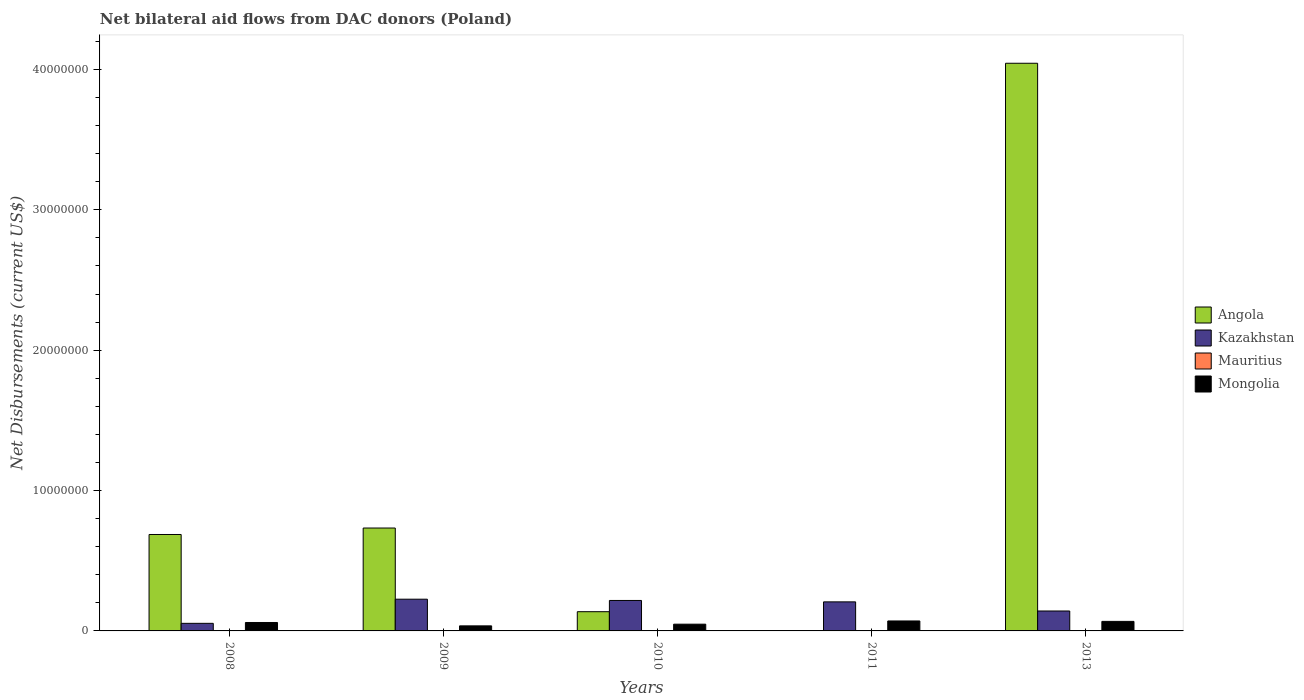How many groups of bars are there?
Your answer should be compact. 5. Are the number of bars per tick equal to the number of legend labels?
Your answer should be compact. No. How many bars are there on the 1st tick from the left?
Offer a terse response. 4. How many bars are there on the 1st tick from the right?
Ensure brevity in your answer.  4. What is the label of the 1st group of bars from the left?
Offer a terse response. 2008. In how many cases, is the number of bars for a given year not equal to the number of legend labels?
Provide a succinct answer. 1. What is the net bilateral aid flows in Mongolia in 2011?
Ensure brevity in your answer.  7.10e+05. Across all years, what is the maximum net bilateral aid flows in Kazakhstan?
Offer a very short reply. 2.26e+06. In which year was the net bilateral aid flows in Mauritius maximum?
Offer a very short reply. 2008. What is the total net bilateral aid flows in Mauritius in the graph?
Provide a succinct answer. 6.00e+04. What is the difference between the net bilateral aid flows in Kazakhstan in 2011 and that in 2013?
Ensure brevity in your answer.  6.50e+05. What is the difference between the net bilateral aid flows in Angola in 2011 and the net bilateral aid flows in Mongolia in 2009?
Offer a terse response. -3.60e+05. What is the average net bilateral aid flows in Angola per year?
Keep it short and to the point. 1.12e+07. In the year 2013, what is the difference between the net bilateral aid flows in Angola and net bilateral aid flows in Mongolia?
Keep it short and to the point. 3.98e+07. In how many years, is the net bilateral aid flows in Mongolia greater than 20000000 US$?
Your answer should be compact. 0. What is the ratio of the net bilateral aid flows in Mongolia in 2010 to that in 2011?
Provide a short and direct response. 0.68. Is the difference between the net bilateral aid flows in Angola in 2008 and 2013 greater than the difference between the net bilateral aid flows in Mongolia in 2008 and 2013?
Your answer should be very brief. No. What is the difference between the highest and the second highest net bilateral aid flows in Kazakhstan?
Offer a very short reply. 9.00e+04. What is the difference between the highest and the lowest net bilateral aid flows in Mongolia?
Ensure brevity in your answer.  3.50e+05. In how many years, is the net bilateral aid flows in Mauritius greater than the average net bilateral aid flows in Mauritius taken over all years?
Keep it short and to the point. 1. Is it the case that in every year, the sum of the net bilateral aid flows in Mauritius and net bilateral aid flows in Mongolia is greater than the sum of net bilateral aid flows in Kazakhstan and net bilateral aid flows in Angola?
Keep it short and to the point. No. Is it the case that in every year, the sum of the net bilateral aid flows in Kazakhstan and net bilateral aid flows in Angola is greater than the net bilateral aid flows in Mauritius?
Provide a short and direct response. Yes. Are all the bars in the graph horizontal?
Ensure brevity in your answer.  No. What is the difference between two consecutive major ticks on the Y-axis?
Ensure brevity in your answer.  1.00e+07. Where does the legend appear in the graph?
Provide a succinct answer. Center right. How are the legend labels stacked?
Your answer should be very brief. Vertical. What is the title of the graph?
Provide a short and direct response. Net bilateral aid flows from DAC donors (Poland). Does "Northern Mariana Islands" appear as one of the legend labels in the graph?
Offer a terse response. No. What is the label or title of the X-axis?
Provide a succinct answer. Years. What is the label or title of the Y-axis?
Give a very brief answer. Net Disbursements (current US$). What is the Net Disbursements (current US$) in Angola in 2008?
Keep it short and to the point. 6.87e+06. What is the Net Disbursements (current US$) of Kazakhstan in 2008?
Keep it short and to the point. 5.40e+05. What is the Net Disbursements (current US$) of Mauritius in 2008?
Offer a very short reply. 2.00e+04. What is the Net Disbursements (current US$) in Angola in 2009?
Your response must be concise. 7.33e+06. What is the Net Disbursements (current US$) of Kazakhstan in 2009?
Give a very brief answer. 2.26e+06. What is the Net Disbursements (current US$) of Mauritius in 2009?
Ensure brevity in your answer.  10000. What is the Net Disbursements (current US$) of Angola in 2010?
Give a very brief answer. 1.37e+06. What is the Net Disbursements (current US$) of Kazakhstan in 2010?
Ensure brevity in your answer.  2.17e+06. What is the Net Disbursements (current US$) of Angola in 2011?
Give a very brief answer. 0. What is the Net Disbursements (current US$) in Kazakhstan in 2011?
Your response must be concise. 2.07e+06. What is the Net Disbursements (current US$) of Mongolia in 2011?
Your answer should be very brief. 7.10e+05. What is the Net Disbursements (current US$) of Angola in 2013?
Give a very brief answer. 4.04e+07. What is the Net Disbursements (current US$) in Kazakhstan in 2013?
Your answer should be very brief. 1.42e+06. What is the Net Disbursements (current US$) in Mongolia in 2013?
Keep it short and to the point. 6.80e+05. Across all years, what is the maximum Net Disbursements (current US$) of Angola?
Your answer should be compact. 4.04e+07. Across all years, what is the maximum Net Disbursements (current US$) in Kazakhstan?
Provide a short and direct response. 2.26e+06. Across all years, what is the maximum Net Disbursements (current US$) of Mongolia?
Give a very brief answer. 7.10e+05. Across all years, what is the minimum Net Disbursements (current US$) in Angola?
Offer a very short reply. 0. Across all years, what is the minimum Net Disbursements (current US$) in Kazakhstan?
Keep it short and to the point. 5.40e+05. What is the total Net Disbursements (current US$) in Angola in the graph?
Keep it short and to the point. 5.60e+07. What is the total Net Disbursements (current US$) in Kazakhstan in the graph?
Make the answer very short. 8.46e+06. What is the total Net Disbursements (current US$) in Mongolia in the graph?
Provide a short and direct response. 2.83e+06. What is the difference between the Net Disbursements (current US$) in Angola in 2008 and that in 2009?
Ensure brevity in your answer.  -4.60e+05. What is the difference between the Net Disbursements (current US$) of Kazakhstan in 2008 and that in 2009?
Offer a very short reply. -1.72e+06. What is the difference between the Net Disbursements (current US$) of Mongolia in 2008 and that in 2009?
Make the answer very short. 2.40e+05. What is the difference between the Net Disbursements (current US$) in Angola in 2008 and that in 2010?
Your answer should be compact. 5.50e+06. What is the difference between the Net Disbursements (current US$) in Kazakhstan in 2008 and that in 2010?
Offer a terse response. -1.63e+06. What is the difference between the Net Disbursements (current US$) in Mauritius in 2008 and that in 2010?
Provide a succinct answer. 10000. What is the difference between the Net Disbursements (current US$) in Mongolia in 2008 and that in 2010?
Your answer should be compact. 1.20e+05. What is the difference between the Net Disbursements (current US$) of Kazakhstan in 2008 and that in 2011?
Provide a succinct answer. -1.53e+06. What is the difference between the Net Disbursements (current US$) of Mauritius in 2008 and that in 2011?
Make the answer very short. 10000. What is the difference between the Net Disbursements (current US$) of Angola in 2008 and that in 2013?
Keep it short and to the point. -3.36e+07. What is the difference between the Net Disbursements (current US$) of Kazakhstan in 2008 and that in 2013?
Offer a very short reply. -8.80e+05. What is the difference between the Net Disbursements (current US$) in Mongolia in 2008 and that in 2013?
Your response must be concise. -8.00e+04. What is the difference between the Net Disbursements (current US$) in Angola in 2009 and that in 2010?
Make the answer very short. 5.96e+06. What is the difference between the Net Disbursements (current US$) of Kazakhstan in 2009 and that in 2010?
Ensure brevity in your answer.  9.00e+04. What is the difference between the Net Disbursements (current US$) of Mongolia in 2009 and that in 2011?
Offer a terse response. -3.50e+05. What is the difference between the Net Disbursements (current US$) in Angola in 2009 and that in 2013?
Offer a very short reply. -3.31e+07. What is the difference between the Net Disbursements (current US$) of Kazakhstan in 2009 and that in 2013?
Your answer should be very brief. 8.40e+05. What is the difference between the Net Disbursements (current US$) in Mongolia in 2009 and that in 2013?
Provide a succinct answer. -3.20e+05. What is the difference between the Net Disbursements (current US$) in Mongolia in 2010 and that in 2011?
Your response must be concise. -2.30e+05. What is the difference between the Net Disbursements (current US$) in Angola in 2010 and that in 2013?
Your answer should be very brief. -3.91e+07. What is the difference between the Net Disbursements (current US$) in Kazakhstan in 2010 and that in 2013?
Your answer should be very brief. 7.50e+05. What is the difference between the Net Disbursements (current US$) of Mauritius in 2010 and that in 2013?
Make the answer very short. 0. What is the difference between the Net Disbursements (current US$) in Mongolia in 2010 and that in 2013?
Your answer should be compact. -2.00e+05. What is the difference between the Net Disbursements (current US$) in Kazakhstan in 2011 and that in 2013?
Your answer should be compact. 6.50e+05. What is the difference between the Net Disbursements (current US$) in Mongolia in 2011 and that in 2013?
Provide a short and direct response. 3.00e+04. What is the difference between the Net Disbursements (current US$) of Angola in 2008 and the Net Disbursements (current US$) of Kazakhstan in 2009?
Your answer should be very brief. 4.61e+06. What is the difference between the Net Disbursements (current US$) in Angola in 2008 and the Net Disbursements (current US$) in Mauritius in 2009?
Provide a succinct answer. 6.86e+06. What is the difference between the Net Disbursements (current US$) in Angola in 2008 and the Net Disbursements (current US$) in Mongolia in 2009?
Provide a short and direct response. 6.51e+06. What is the difference between the Net Disbursements (current US$) in Kazakhstan in 2008 and the Net Disbursements (current US$) in Mauritius in 2009?
Provide a short and direct response. 5.30e+05. What is the difference between the Net Disbursements (current US$) of Mauritius in 2008 and the Net Disbursements (current US$) of Mongolia in 2009?
Ensure brevity in your answer.  -3.40e+05. What is the difference between the Net Disbursements (current US$) of Angola in 2008 and the Net Disbursements (current US$) of Kazakhstan in 2010?
Offer a very short reply. 4.70e+06. What is the difference between the Net Disbursements (current US$) in Angola in 2008 and the Net Disbursements (current US$) in Mauritius in 2010?
Ensure brevity in your answer.  6.86e+06. What is the difference between the Net Disbursements (current US$) in Angola in 2008 and the Net Disbursements (current US$) in Mongolia in 2010?
Offer a very short reply. 6.39e+06. What is the difference between the Net Disbursements (current US$) of Kazakhstan in 2008 and the Net Disbursements (current US$) of Mauritius in 2010?
Provide a succinct answer. 5.30e+05. What is the difference between the Net Disbursements (current US$) of Mauritius in 2008 and the Net Disbursements (current US$) of Mongolia in 2010?
Your response must be concise. -4.60e+05. What is the difference between the Net Disbursements (current US$) of Angola in 2008 and the Net Disbursements (current US$) of Kazakhstan in 2011?
Keep it short and to the point. 4.80e+06. What is the difference between the Net Disbursements (current US$) in Angola in 2008 and the Net Disbursements (current US$) in Mauritius in 2011?
Offer a terse response. 6.86e+06. What is the difference between the Net Disbursements (current US$) of Angola in 2008 and the Net Disbursements (current US$) of Mongolia in 2011?
Your response must be concise. 6.16e+06. What is the difference between the Net Disbursements (current US$) in Kazakhstan in 2008 and the Net Disbursements (current US$) in Mauritius in 2011?
Offer a terse response. 5.30e+05. What is the difference between the Net Disbursements (current US$) of Mauritius in 2008 and the Net Disbursements (current US$) of Mongolia in 2011?
Provide a short and direct response. -6.90e+05. What is the difference between the Net Disbursements (current US$) in Angola in 2008 and the Net Disbursements (current US$) in Kazakhstan in 2013?
Your response must be concise. 5.45e+06. What is the difference between the Net Disbursements (current US$) in Angola in 2008 and the Net Disbursements (current US$) in Mauritius in 2013?
Your response must be concise. 6.86e+06. What is the difference between the Net Disbursements (current US$) of Angola in 2008 and the Net Disbursements (current US$) of Mongolia in 2013?
Ensure brevity in your answer.  6.19e+06. What is the difference between the Net Disbursements (current US$) of Kazakhstan in 2008 and the Net Disbursements (current US$) of Mauritius in 2013?
Keep it short and to the point. 5.30e+05. What is the difference between the Net Disbursements (current US$) of Mauritius in 2008 and the Net Disbursements (current US$) of Mongolia in 2013?
Give a very brief answer. -6.60e+05. What is the difference between the Net Disbursements (current US$) of Angola in 2009 and the Net Disbursements (current US$) of Kazakhstan in 2010?
Ensure brevity in your answer.  5.16e+06. What is the difference between the Net Disbursements (current US$) of Angola in 2009 and the Net Disbursements (current US$) of Mauritius in 2010?
Ensure brevity in your answer.  7.32e+06. What is the difference between the Net Disbursements (current US$) in Angola in 2009 and the Net Disbursements (current US$) in Mongolia in 2010?
Keep it short and to the point. 6.85e+06. What is the difference between the Net Disbursements (current US$) in Kazakhstan in 2009 and the Net Disbursements (current US$) in Mauritius in 2010?
Your answer should be very brief. 2.25e+06. What is the difference between the Net Disbursements (current US$) in Kazakhstan in 2009 and the Net Disbursements (current US$) in Mongolia in 2010?
Your answer should be compact. 1.78e+06. What is the difference between the Net Disbursements (current US$) of Mauritius in 2009 and the Net Disbursements (current US$) of Mongolia in 2010?
Offer a very short reply. -4.70e+05. What is the difference between the Net Disbursements (current US$) of Angola in 2009 and the Net Disbursements (current US$) of Kazakhstan in 2011?
Make the answer very short. 5.26e+06. What is the difference between the Net Disbursements (current US$) of Angola in 2009 and the Net Disbursements (current US$) of Mauritius in 2011?
Provide a short and direct response. 7.32e+06. What is the difference between the Net Disbursements (current US$) of Angola in 2009 and the Net Disbursements (current US$) of Mongolia in 2011?
Offer a very short reply. 6.62e+06. What is the difference between the Net Disbursements (current US$) in Kazakhstan in 2009 and the Net Disbursements (current US$) in Mauritius in 2011?
Your answer should be compact. 2.25e+06. What is the difference between the Net Disbursements (current US$) in Kazakhstan in 2009 and the Net Disbursements (current US$) in Mongolia in 2011?
Make the answer very short. 1.55e+06. What is the difference between the Net Disbursements (current US$) of Mauritius in 2009 and the Net Disbursements (current US$) of Mongolia in 2011?
Provide a short and direct response. -7.00e+05. What is the difference between the Net Disbursements (current US$) of Angola in 2009 and the Net Disbursements (current US$) of Kazakhstan in 2013?
Offer a terse response. 5.91e+06. What is the difference between the Net Disbursements (current US$) of Angola in 2009 and the Net Disbursements (current US$) of Mauritius in 2013?
Offer a very short reply. 7.32e+06. What is the difference between the Net Disbursements (current US$) of Angola in 2009 and the Net Disbursements (current US$) of Mongolia in 2013?
Ensure brevity in your answer.  6.65e+06. What is the difference between the Net Disbursements (current US$) in Kazakhstan in 2009 and the Net Disbursements (current US$) in Mauritius in 2013?
Ensure brevity in your answer.  2.25e+06. What is the difference between the Net Disbursements (current US$) of Kazakhstan in 2009 and the Net Disbursements (current US$) of Mongolia in 2013?
Make the answer very short. 1.58e+06. What is the difference between the Net Disbursements (current US$) of Mauritius in 2009 and the Net Disbursements (current US$) of Mongolia in 2013?
Ensure brevity in your answer.  -6.70e+05. What is the difference between the Net Disbursements (current US$) of Angola in 2010 and the Net Disbursements (current US$) of Kazakhstan in 2011?
Your answer should be compact. -7.00e+05. What is the difference between the Net Disbursements (current US$) of Angola in 2010 and the Net Disbursements (current US$) of Mauritius in 2011?
Your answer should be compact. 1.36e+06. What is the difference between the Net Disbursements (current US$) in Kazakhstan in 2010 and the Net Disbursements (current US$) in Mauritius in 2011?
Ensure brevity in your answer.  2.16e+06. What is the difference between the Net Disbursements (current US$) of Kazakhstan in 2010 and the Net Disbursements (current US$) of Mongolia in 2011?
Your response must be concise. 1.46e+06. What is the difference between the Net Disbursements (current US$) of Mauritius in 2010 and the Net Disbursements (current US$) of Mongolia in 2011?
Give a very brief answer. -7.00e+05. What is the difference between the Net Disbursements (current US$) in Angola in 2010 and the Net Disbursements (current US$) in Kazakhstan in 2013?
Provide a short and direct response. -5.00e+04. What is the difference between the Net Disbursements (current US$) of Angola in 2010 and the Net Disbursements (current US$) of Mauritius in 2013?
Provide a short and direct response. 1.36e+06. What is the difference between the Net Disbursements (current US$) of Angola in 2010 and the Net Disbursements (current US$) of Mongolia in 2013?
Provide a succinct answer. 6.90e+05. What is the difference between the Net Disbursements (current US$) of Kazakhstan in 2010 and the Net Disbursements (current US$) of Mauritius in 2013?
Your answer should be compact. 2.16e+06. What is the difference between the Net Disbursements (current US$) of Kazakhstan in 2010 and the Net Disbursements (current US$) of Mongolia in 2013?
Your answer should be compact. 1.49e+06. What is the difference between the Net Disbursements (current US$) of Mauritius in 2010 and the Net Disbursements (current US$) of Mongolia in 2013?
Make the answer very short. -6.70e+05. What is the difference between the Net Disbursements (current US$) of Kazakhstan in 2011 and the Net Disbursements (current US$) of Mauritius in 2013?
Provide a short and direct response. 2.06e+06. What is the difference between the Net Disbursements (current US$) in Kazakhstan in 2011 and the Net Disbursements (current US$) in Mongolia in 2013?
Provide a short and direct response. 1.39e+06. What is the difference between the Net Disbursements (current US$) of Mauritius in 2011 and the Net Disbursements (current US$) of Mongolia in 2013?
Offer a terse response. -6.70e+05. What is the average Net Disbursements (current US$) in Angola per year?
Keep it short and to the point. 1.12e+07. What is the average Net Disbursements (current US$) of Kazakhstan per year?
Offer a terse response. 1.69e+06. What is the average Net Disbursements (current US$) of Mauritius per year?
Your answer should be very brief. 1.20e+04. What is the average Net Disbursements (current US$) of Mongolia per year?
Offer a very short reply. 5.66e+05. In the year 2008, what is the difference between the Net Disbursements (current US$) in Angola and Net Disbursements (current US$) in Kazakhstan?
Offer a very short reply. 6.33e+06. In the year 2008, what is the difference between the Net Disbursements (current US$) in Angola and Net Disbursements (current US$) in Mauritius?
Provide a short and direct response. 6.85e+06. In the year 2008, what is the difference between the Net Disbursements (current US$) of Angola and Net Disbursements (current US$) of Mongolia?
Make the answer very short. 6.27e+06. In the year 2008, what is the difference between the Net Disbursements (current US$) of Kazakhstan and Net Disbursements (current US$) of Mauritius?
Make the answer very short. 5.20e+05. In the year 2008, what is the difference between the Net Disbursements (current US$) of Mauritius and Net Disbursements (current US$) of Mongolia?
Your response must be concise. -5.80e+05. In the year 2009, what is the difference between the Net Disbursements (current US$) in Angola and Net Disbursements (current US$) in Kazakhstan?
Keep it short and to the point. 5.07e+06. In the year 2009, what is the difference between the Net Disbursements (current US$) in Angola and Net Disbursements (current US$) in Mauritius?
Your answer should be very brief. 7.32e+06. In the year 2009, what is the difference between the Net Disbursements (current US$) in Angola and Net Disbursements (current US$) in Mongolia?
Offer a very short reply. 6.97e+06. In the year 2009, what is the difference between the Net Disbursements (current US$) in Kazakhstan and Net Disbursements (current US$) in Mauritius?
Your response must be concise. 2.25e+06. In the year 2009, what is the difference between the Net Disbursements (current US$) of Kazakhstan and Net Disbursements (current US$) of Mongolia?
Make the answer very short. 1.90e+06. In the year 2009, what is the difference between the Net Disbursements (current US$) of Mauritius and Net Disbursements (current US$) of Mongolia?
Your answer should be very brief. -3.50e+05. In the year 2010, what is the difference between the Net Disbursements (current US$) of Angola and Net Disbursements (current US$) of Kazakhstan?
Offer a terse response. -8.00e+05. In the year 2010, what is the difference between the Net Disbursements (current US$) of Angola and Net Disbursements (current US$) of Mauritius?
Offer a terse response. 1.36e+06. In the year 2010, what is the difference between the Net Disbursements (current US$) in Angola and Net Disbursements (current US$) in Mongolia?
Give a very brief answer. 8.90e+05. In the year 2010, what is the difference between the Net Disbursements (current US$) of Kazakhstan and Net Disbursements (current US$) of Mauritius?
Provide a succinct answer. 2.16e+06. In the year 2010, what is the difference between the Net Disbursements (current US$) of Kazakhstan and Net Disbursements (current US$) of Mongolia?
Make the answer very short. 1.69e+06. In the year 2010, what is the difference between the Net Disbursements (current US$) in Mauritius and Net Disbursements (current US$) in Mongolia?
Offer a terse response. -4.70e+05. In the year 2011, what is the difference between the Net Disbursements (current US$) of Kazakhstan and Net Disbursements (current US$) of Mauritius?
Make the answer very short. 2.06e+06. In the year 2011, what is the difference between the Net Disbursements (current US$) in Kazakhstan and Net Disbursements (current US$) in Mongolia?
Your answer should be compact. 1.36e+06. In the year 2011, what is the difference between the Net Disbursements (current US$) of Mauritius and Net Disbursements (current US$) of Mongolia?
Your response must be concise. -7.00e+05. In the year 2013, what is the difference between the Net Disbursements (current US$) in Angola and Net Disbursements (current US$) in Kazakhstan?
Keep it short and to the point. 3.90e+07. In the year 2013, what is the difference between the Net Disbursements (current US$) in Angola and Net Disbursements (current US$) in Mauritius?
Your answer should be very brief. 4.04e+07. In the year 2013, what is the difference between the Net Disbursements (current US$) of Angola and Net Disbursements (current US$) of Mongolia?
Offer a terse response. 3.98e+07. In the year 2013, what is the difference between the Net Disbursements (current US$) in Kazakhstan and Net Disbursements (current US$) in Mauritius?
Provide a succinct answer. 1.41e+06. In the year 2013, what is the difference between the Net Disbursements (current US$) in Kazakhstan and Net Disbursements (current US$) in Mongolia?
Provide a succinct answer. 7.40e+05. In the year 2013, what is the difference between the Net Disbursements (current US$) in Mauritius and Net Disbursements (current US$) in Mongolia?
Ensure brevity in your answer.  -6.70e+05. What is the ratio of the Net Disbursements (current US$) in Angola in 2008 to that in 2009?
Keep it short and to the point. 0.94. What is the ratio of the Net Disbursements (current US$) of Kazakhstan in 2008 to that in 2009?
Your response must be concise. 0.24. What is the ratio of the Net Disbursements (current US$) of Mongolia in 2008 to that in 2009?
Keep it short and to the point. 1.67. What is the ratio of the Net Disbursements (current US$) in Angola in 2008 to that in 2010?
Offer a terse response. 5.01. What is the ratio of the Net Disbursements (current US$) of Kazakhstan in 2008 to that in 2010?
Your response must be concise. 0.25. What is the ratio of the Net Disbursements (current US$) in Mauritius in 2008 to that in 2010?
Offer a terse response. 2. What is the ratio of the Net Disbursements (current US$) in Mongolia in 2008 to that in 2010?
Make the answer very short. 1.25. What is the ratio of the Net Disbursements (current US$) in Kazakhstan in 2008 to that in 2011?
Offer a terse response. 0.26. What is the ratio of the Net Disbursements (current US$) of Mauritius in 2008 to that in 2011?
Make the answer very short. 2. What is the ratio of the Net Disbursements (current US$) of Mongolia in 2008 to that in 2011?
Offer a terse response. 0.85. What is the ratio of the Net Disbursements (current US$) in Angola in 2008 to that in 2013?
Offer a terse response. 0.17. What is the ratio of the Net Disbursements (current US$) in Kazakhstan in 2008 to that in 2013?
Provide a short and direct response. 0.38. What is the ratio of the Net Disbursements (current US$) in Mauritius in 2008 to that in 2013?
Provide a succinct answer. 2. What is the ratio of the Net Disbursements (current US$) in Mongolia in 2008 to that in 2013?
Your answer should be very brief. 0.88. What is the ratio of the Net Disbursements (current US$) in Angola in 2009 to that in 2010?
Provide a succinct answer. 5.35. What is the ratio of the Net Disbursements (current US$) of Kazakhstan in 2009 to that in 2010?
Offer a terse response. 1.04. What is the ratio of the Net Disbursements (current US$) in Mauritius in 2009 to that in 2010?
Your response must be concise. 1. What is the ratio of the Net Disbursements (current US$) in Kazakhstan in 2009 to that in 2011?
Make the answer very short. 1.09. What is the ratio of the Net Disbursements (current US$) in Mongolia in 2009 to that in 2011?
Your answer should be very brief. 0.51. What is the ratio of the Net Disbursements (current US$) of Angola in 2009 to that in 2013?
Your answer should be compact. 0.18. What is the ratio of the Net Disbursements (current US$) in Kazakhstan in 2009 to that in 2013?
Ensure brevity in your answer.  1.59. What is the ratio of the Net Disbursements (current US$) in Mauritius in 2009 to that in 2013?
Your answer should be compact. 1. What is the ratio of the Net Disbursements (current US$) of Mongolia in 2009 to that in 2013?
Offer a very short reply. 0.53. What is the ratio of the Net Disbursements (current US$) of Kazakhstan in 2010 to that in 2011?
Offer a very short reply. 1.05. What is the ratio of the Net Disbursements (current US$) in Mongolia in 2010 to that in 2011?
Ensure brevity in your answer.  0.68. What is the ratio of the Net Disbursements (current US$) in Angola in 2010 to that in 2013?
Offer a very short reply. 0.03. What is the ratio of the Net Disbursements (current US$) of Kazakhstan in 2010 to that in 2013?
Offer a very short reply. 1.53. What is the ratio of the Net Disbursements (current US$) of Mongolia in 2010 to that in 2013?
Give a very brief answer. 0.71. What is the ratio of the Net Disbursements (current US$) of Kazakhstan in 2011 to that in 2013?
Make the answer very short. 1.46. What is the ratio of the Net Disbursements (current US$) in Mongolia in 2011 to that in 2013?
Your response must be concise. 1.04. What is the difference between the highest and the second highest Net Disbursements (current US$) of Angola?
Offer a very short reply. 3.31e+07. What is the difference between the highest and the second highest Net Disbursements (current US$) in Kazakhstan?
Your answer should be compact. 9.00e+04. What is the difference between the highest and the second highest Net Disbursements (current US$) of Mauritius?
Make the answer very short. 10000. What is the difference between the highest and the lowest Net Disbursements (current US$) in Angola?
Make the answer very short. 4.04e+07. What is the difference between the highest and the lowest Net Disbursements (current US$) in Kazakhstan?
Ensure brevity in your answer.  1.72e+06. What is the difference between the highest and the lowest Net Disbursements (current US$) of Mongolia?
Your answer should be very brief. 3.50e+05. 